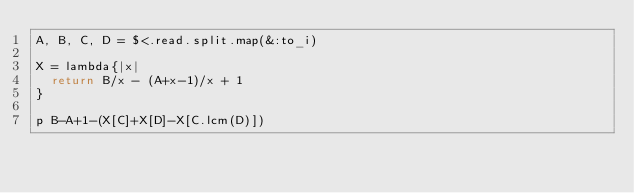Convert code to text. <code><loc_0><loc_0><loc_500><loc_500><_Ruby_>A, B, C, D = $<.read.split.map(&:to_i)

X = lambda{|x|
	return B/x - (A+x-1)/x + 1
}

p B-A+1-(X[C]+X[D]-X[C.lcm(D)])
</code> 